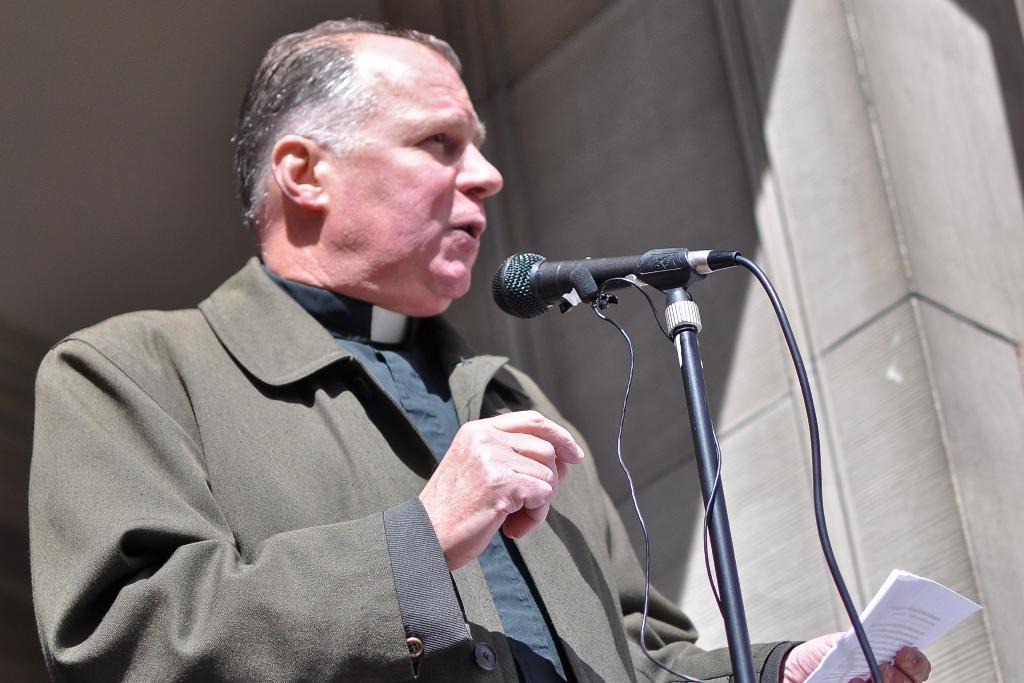Could you give a brief overview of what you see in this image? In this image we can see a man standing and holding a paper in his hand. In front of the man a mic is placed. 